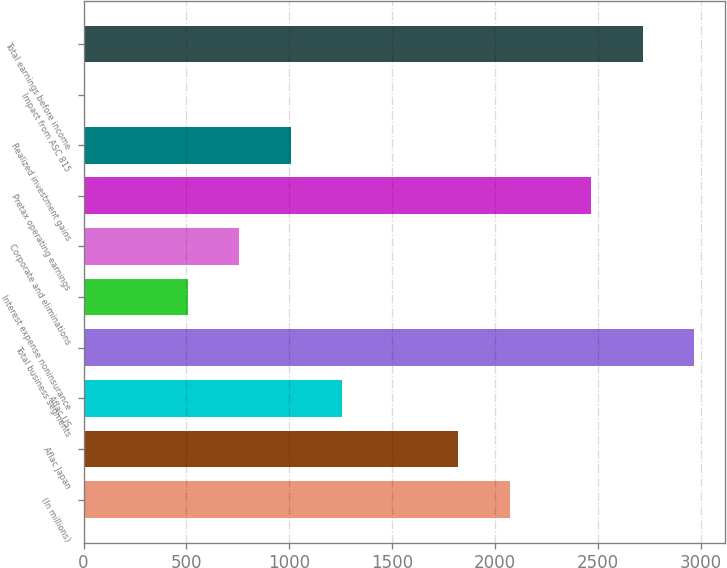Convert chart to OTSL. <chart><loc_0><loc_0><loc_500><loc_500><bar_chart><fcel>(In millions)<fcel>Aflac Japan<fcel>Aflac US<fcel>Total business segments<fcel>Interest expense noninsurance<fcel>Corporate and eliminations<fcel>Pretax operating earnings<fcel>Realized investment gains<fcel>Impact from ASC 815<fcel>Total earnings before income<nl><fcel>2071.9<fcel>1821<fcel>1258.5<fcel>2968.8<fcel>505.8<fcel>756.7<fcel>2467<fcel>1007.6<fcel>4<fcel>2717.9<nl></chart> 